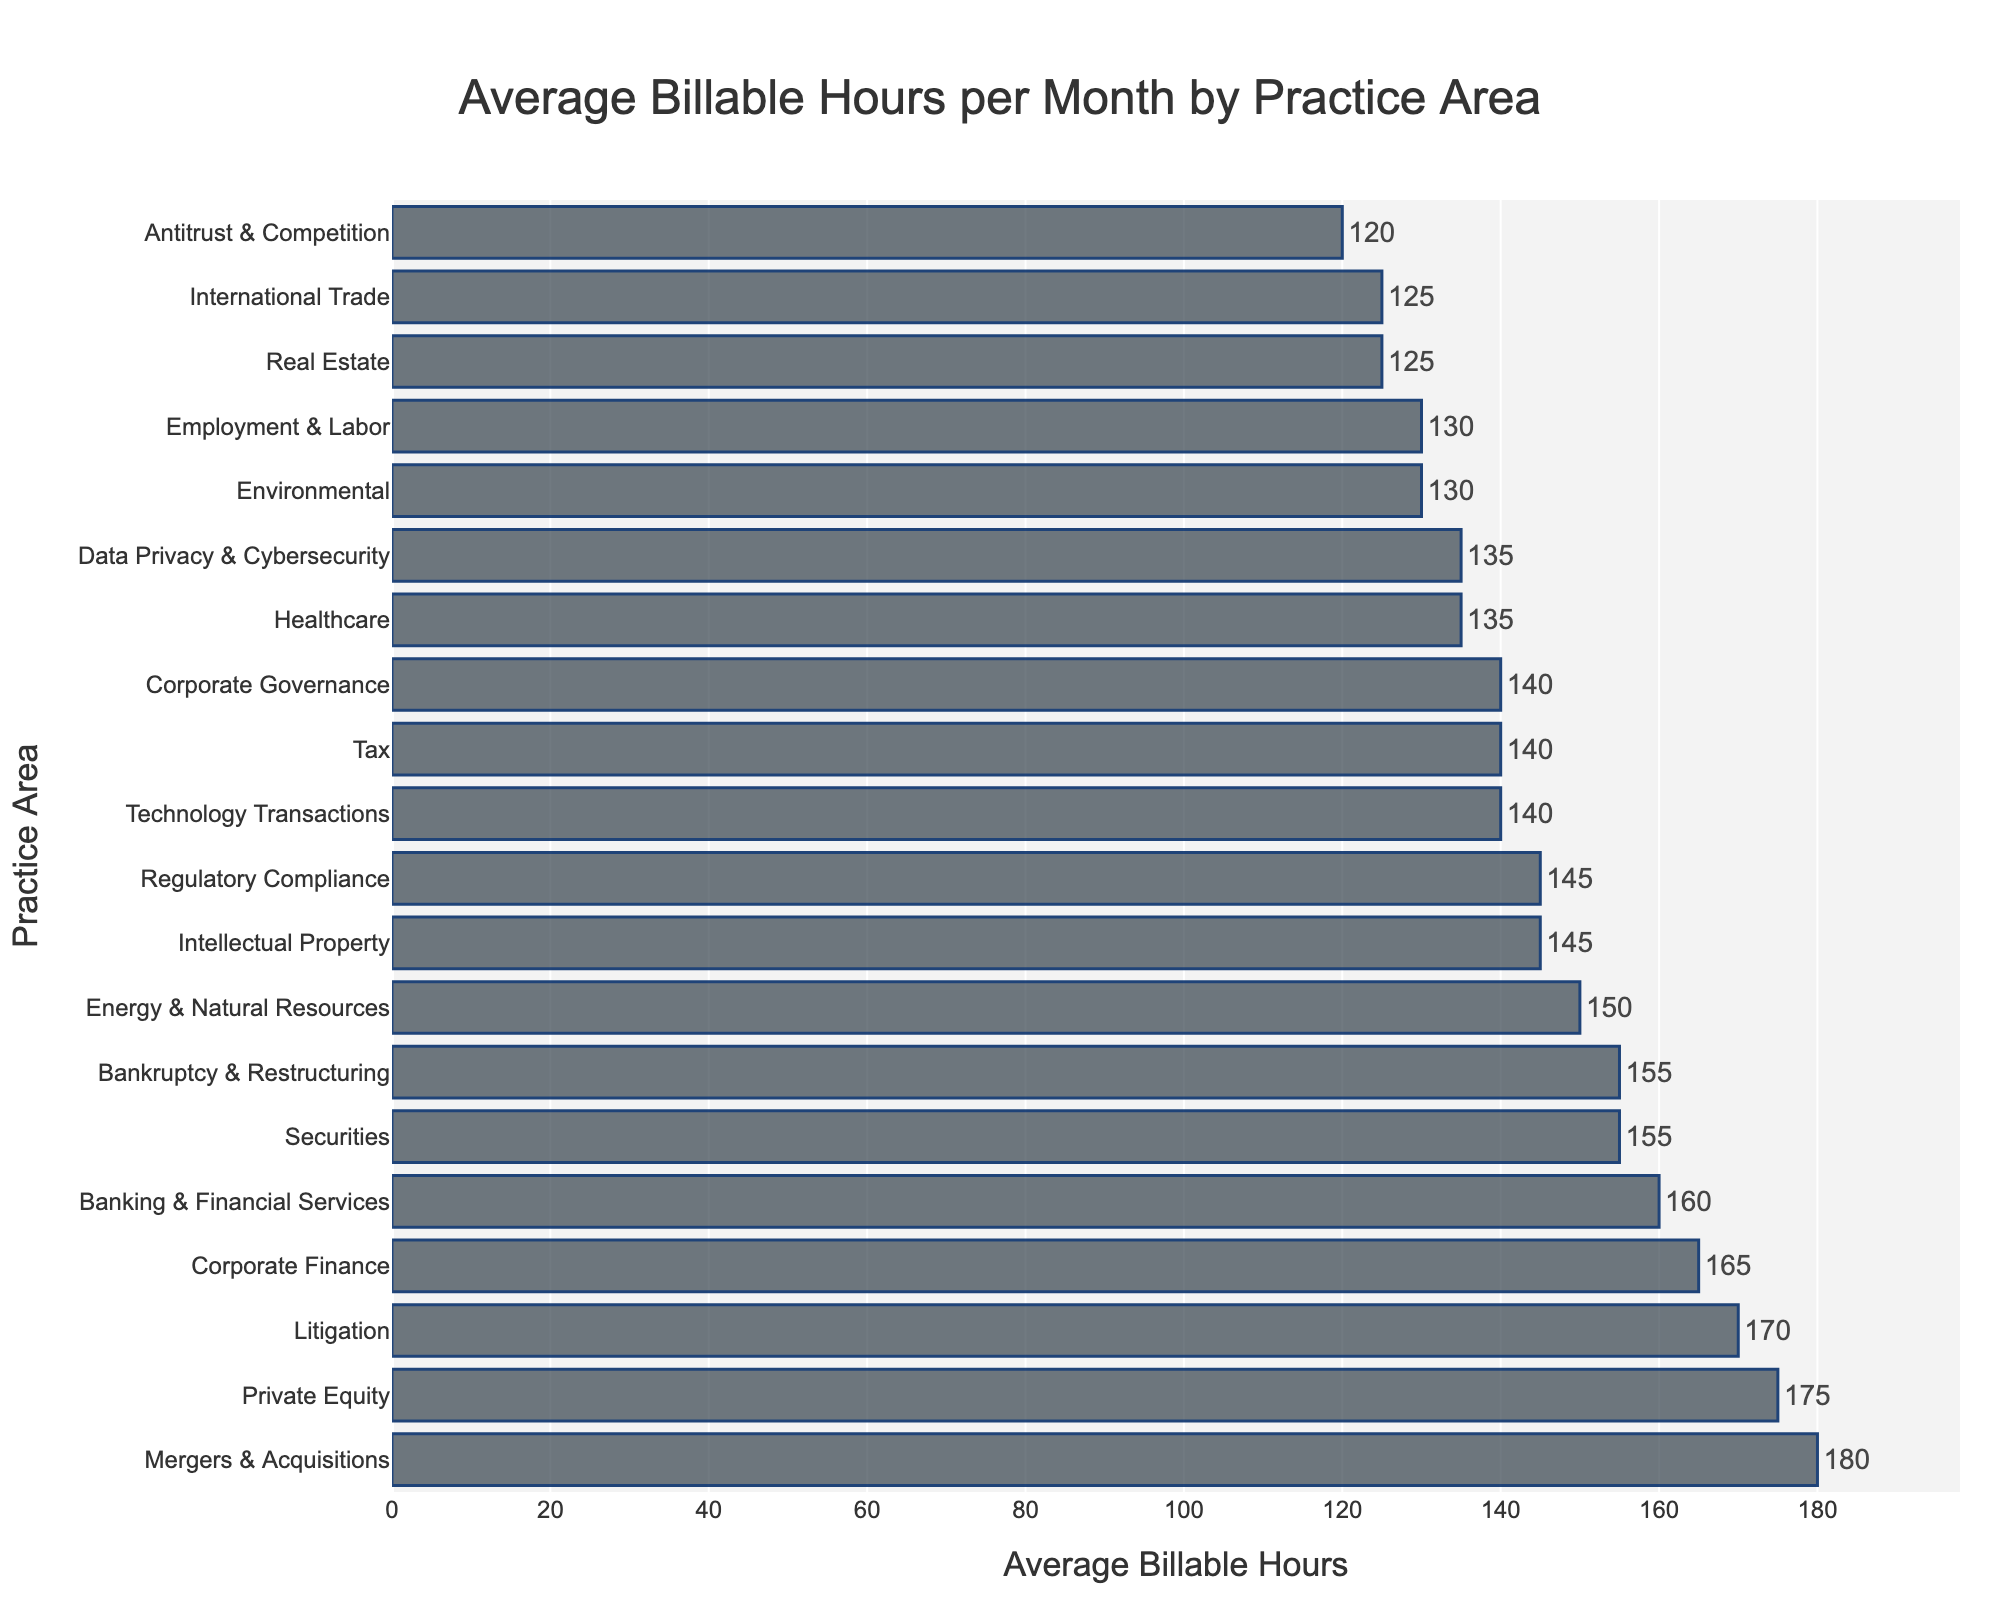Which practice area has the highest average billable hours per month? The bar chart displays various practice areas and their corresponding billable hours. The tallest bar represents the highest value, which is found to be "Mergers & Acquisitions" with 180 hours.
Answer: Mergers & Acquisitions How many practice areas have an average billable hour per month of 145? By observing the bars, we identify practice areas with their values equal to 145. These areas are "Intellectual Property" and "Regulatory Compliance."
Answer: 2 Which practice area has a lower average billable hour, Intellectual Property or Corporate Governance? The bar representing Intellectual Property shows 145 hours, while Corporate Governance shows 140 hours. Since 140 hours is less than 145 hours, Corporate Governance has lower billable hours.
Answer: Corporate Governance What is the difference in average billable hours per month between Mergers & Acquisitions and Real Estate? Find the values for both practice areas (Mergers & Acquisitions: 180, Real Estate: 125) and subtract the smaller from the larger. 180 - 125 = 55.
Answer: 55 Which practice area has the closest average billable hours per month to Healthcare? Healthcare shows 135 hours. Comparing nearby values, Data Privacy & Cybersecurity also shows 135 hours. Thus, both have the exact same value.
Answer: Data Privacy & Cybersecurity What is the total average billable hours per month for the top 3 practice areas? Identify the top 3 practice areas (Mergers & Acquisitions: 180, Private Equity: 175, Litigation: 170). Sum these values, 180 + 175 + 170 = 525.
Answer: 525 Which has higher average billable hours per month, Securities or Employment & Labor? Securities shows 155 hours, while Employment & Labor shows 130 hours. Since 155 is greater than 130, Securities has higher billable hours.
Answer: Securities How many practice areas have average billable hours greater than 150? By counting the bars with values above 150, we find Mergers & Acquisitions, Corporate Finance, Securities, Banking & Financial Services, Litigation, and Private Equity.
Answer: 6 Which practice areas have the same average billable hours per month? Checking for identical values, we find Intellectual Property and Regulatory Compliance both have 145 hours, and Healthcare and Data Privacy & Cybersecurity both have 135 hours.
Answer: Intellectual Property and Regulatory Compliance; Healthcare and Data Privacy & Cybersecurity 